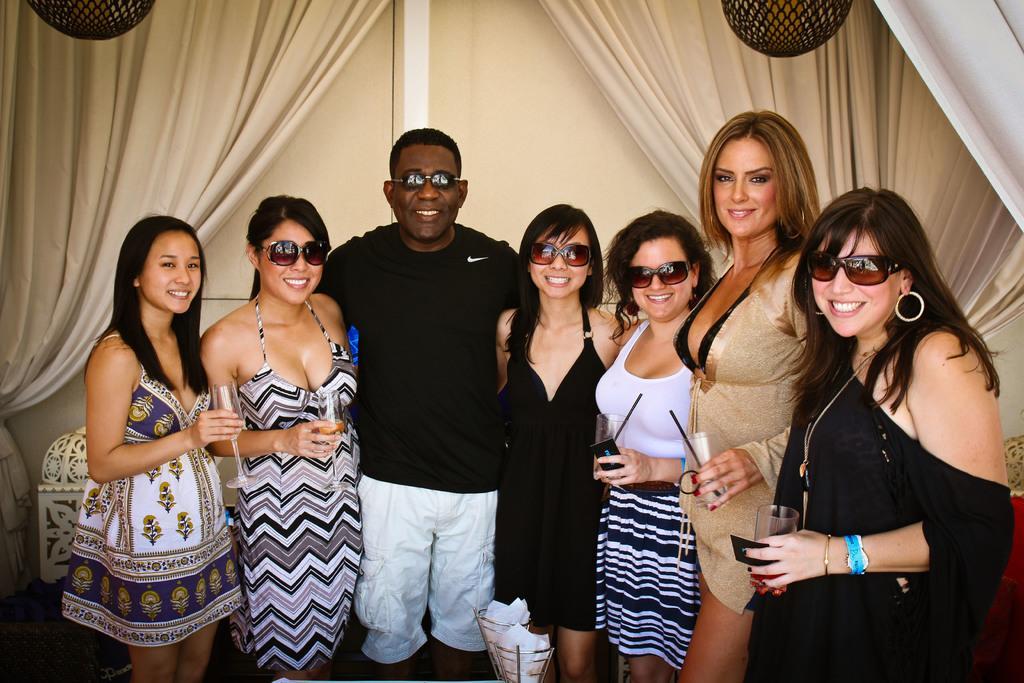How would you summarize this image in a sentence or two? Group of people standing and these persons are holding glasses. On the background we can see wall and curtains. 